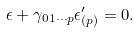<formula> <loc_0><loc_0><loc_500><loc_500>\epsilon + \gamma _ { 0 1 \cdots p } \epsilon _ { ( p ) } ^ { \prime } = 0 .</formula> 